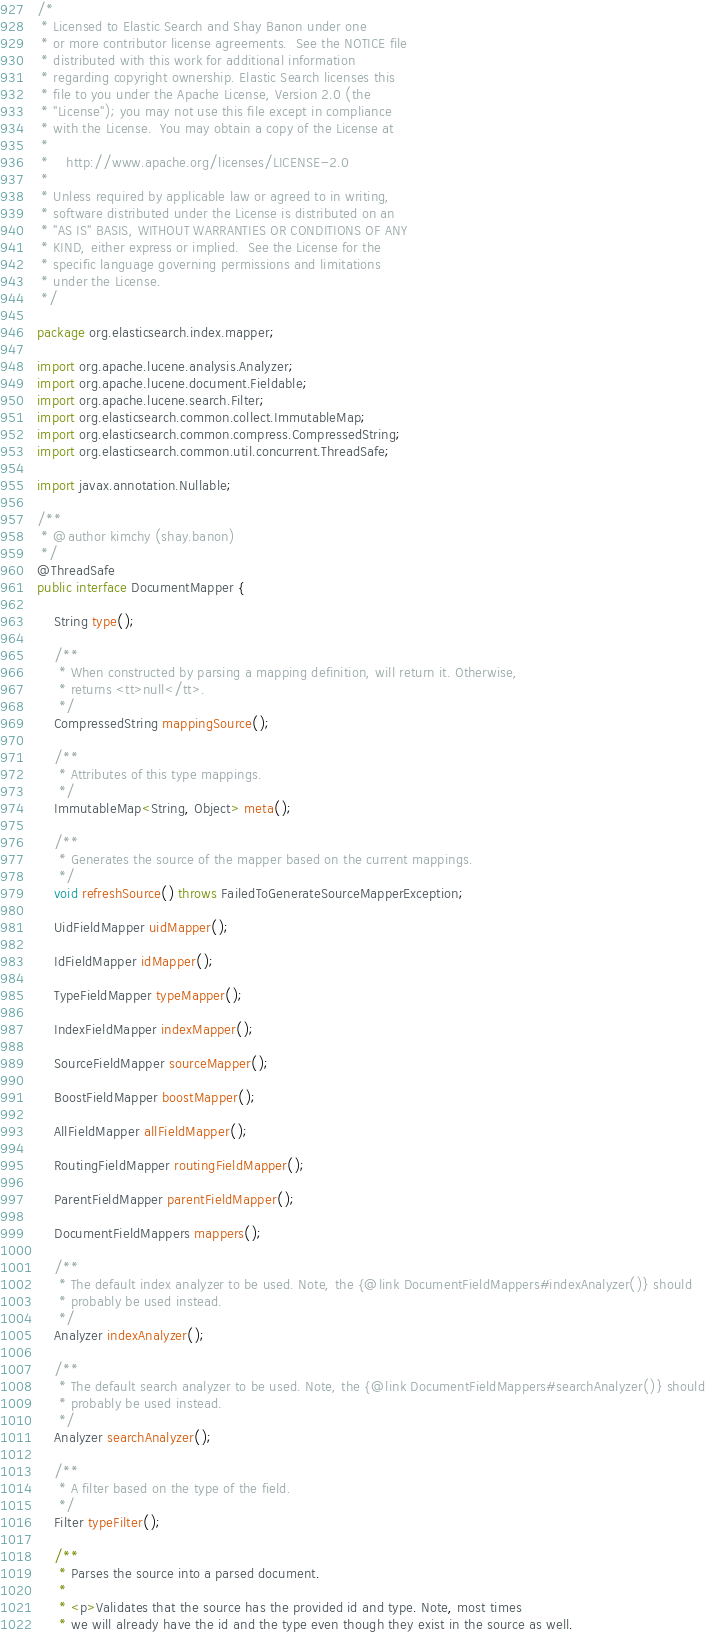<code> <loc_0><loc_0><loc_500><loc_500><_Java_>/*
 * Licensed to Elastic Search and Shay Banon under one
 * or more contributor license agreements.  See the NOTICE file
 * distributed with this work for additional information
 * regarding copyright ownership. Elastic Search licenses this
 * file to you under the Apache License, Version 2.0 (the
 * "License"); you may not use this file except in compliance
 * with the License.  You may obtain a copy of the License at
 *
 *    http://www.apache.org/licenses/LICENSE-2.0
 *
 * Unless required by applicable law or agreed to in writing,
 * software distributed under the License is distributed on an
 * "AS IS" BASIS, WITHOUT WARRANTIES OR CONDITIONS OF ANY
 * KIND, either express or implied.  See the License for the
 * specific language governing permissions and limitations
 * under the License.
 */

package org.elasticsearch.index.mapper;

import org.apache.lucene.analysis.Analyzer;
import org.apache.lucene.document.Fieldable;
import org.apache.lucene.search.Filter;
import org.elasticsearch.common.collect.ImmutableMap;
import org.elasticsearch.common.compress.CompressedString;
import org.elasticsearch.common.util.concurrent.ThreadSafe;

import javax.annotation.Nullable;

/**
 * @author kimchy (shay.banon)
 */
@ThreadSafe
public interface DocumentMapper {

    String type();

    /**
     * When constructed by parsing a mapping definition, will return it. Otherwise,
     * returns <tt>null</tt>.
     */
    CompressedString mappingSource();

    /**
     * Attributes of this type mappings.
     */
    ImmutableMap<String, Object> meta();

    /**
     * Generates the source of the mapper based on the current mappings.
     */
    void refreshSource() throws FailedToGenerateSourceMapperException;

    UidFieldMapper uidMapper();

    IdFieldMapper idMapper();

    TypeFieldMapper typeMapper();

    IndexFieldMapper indexMapper();

    SourceFieldMapper sourceMapper();

    BoostFieldMapper boostMapper();

    AllFieldMapper allFieldMapper();

    RoutingFieldMapper routingFieldMapper();

    ParentFieldMapper parentFieldMapper();

    DocumentFieldMappers mappers();

    /**
     * The default index analyzer to be used. Note, the {@link DocumentFieldMappers#indexAnalyzer()} should
     * probably be used instead.
     */
    Analyzer indexAnalyzer();

    /**
     * The default search analyzer to be used. Note, the {@link DocumentFieldMappers#searchAnalyzer()} should
     * probably be used instead.
     */
    Analyzer searchAnalyzer();

    /**
     * A filter based on the type of the field.
     */
    Filter typeFilter();

    /**
     * Parses the source into a parsed document.
     *
     * <p>Validates that the source has the provided id and type. Note, most times
     * we will already have the id and the type even though they exist in the source as well.</code> 